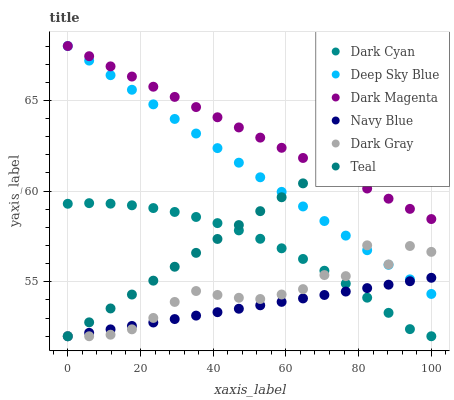Does Navy Blue have the minimum area under the curve?
Answer yes or no. Yes. Does Dark Magenta have the maximum area under the curve?
Answer yes or no. Yes. Does Dark Gray have the minimum area under the curve?
Answer yes or no. No. Does Dark Gray have the maximum area under the curve?
Answer yes or no. No. Is Dark Magenta the smoothest?
Answer yes or no. Yes. Is Dark Gray the roughest?
Answer yes or no. Yes. Is Navy Blue the smoothest?
Answer yes or no. No. Is Navy Blue the roughest?
Answer yes or no. No. Does Navy Blue have the lowest value?
Answer yes or no. Yes. Does Deep Sky Blue have the lowest value?
Answer yes or no. No. Does Deep Sky Blue have the highest value?
Answer yes or no. Yes. Does Dark Gray have the highest value?
Answer yes or no. No. Is Dark Cyan less than Dark Magenta?
Answer yes or no. Yes. Is Dark Magenta greater than Dark Cyan?
Answer yes or no. Yes. Does Navy Blue intersect Teal?
Answer yes or no. Yes. Is Navy Blue less than Teal?
Answer yes or no. No. Is Navy Blue greater than Teal?
Answer yes or no. No. Does Dark Cyan intersect Dark Magenta?
Answer yes or no. No. 